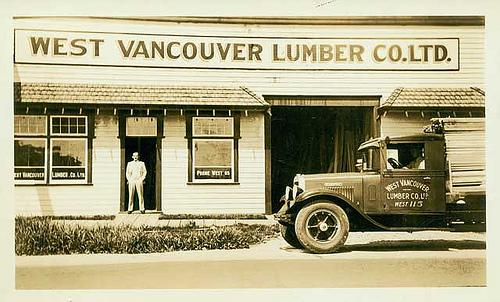Question: what is vehile is used to make the delivery?
Choices:
A. A van.
B. Truck.
C. A bus.
D. An airplane.
Answer with the letter. Answer: B Question: where was picture taken?
Choices:
A. On the street.
B. On the sidewalk.
C. Next to a building.
D. In a car.
Answer with the letter. Answer: A Question: what company is this?
Choices:
A. Comcast.
B. Taco Bell.
C. Urban Outfitters.
D. West Vancouver Lumber Co. Ltd.
Answer with the letter. Answer: D Question: how many people are in the photo?
Choices:
A. Three.
B. Four.
C. Two.
D. Five.
Answer with the letter. Answer: C Question: who is standing in the doorway?
Choices:
A. Owner.
B. My friend.
C. An old woman.
D. The realtor.
Answer with the letter. Answer: A Question: what shape are the tires on the truck?
Choices:
A. Square.
B. Rectangle.
C. Circle.
D. Oval.
Answer with the letter. Answer: C 